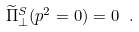Convert formula to latex. <formula><loc_0><loc_0><loc_500><loc_500>\widetilde { \Pi } _ { \perp } ^ { S } ( p ^ { 2 } = 0 ) = 0 \ .</formula> 